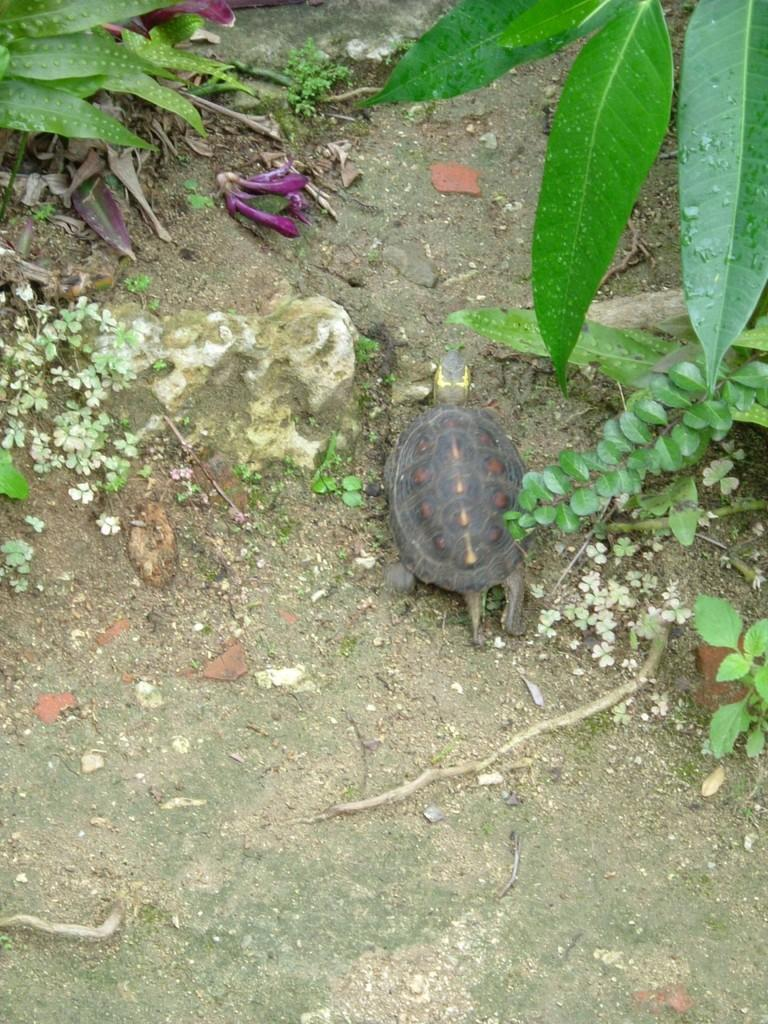What type of animal can be seen on the land in the image? There is a tortoise on the land in the image. What type of vegetation is present in the image? There are flowers, leaves, and plants visible in the image. Where are the leaves located in the image? There are leaves visible on the plants and in the top right corner of the image. What type of jewel is the tortoise wearing in the image? There is no jewel present in the image; the tortoise is not wearing any accessories. 